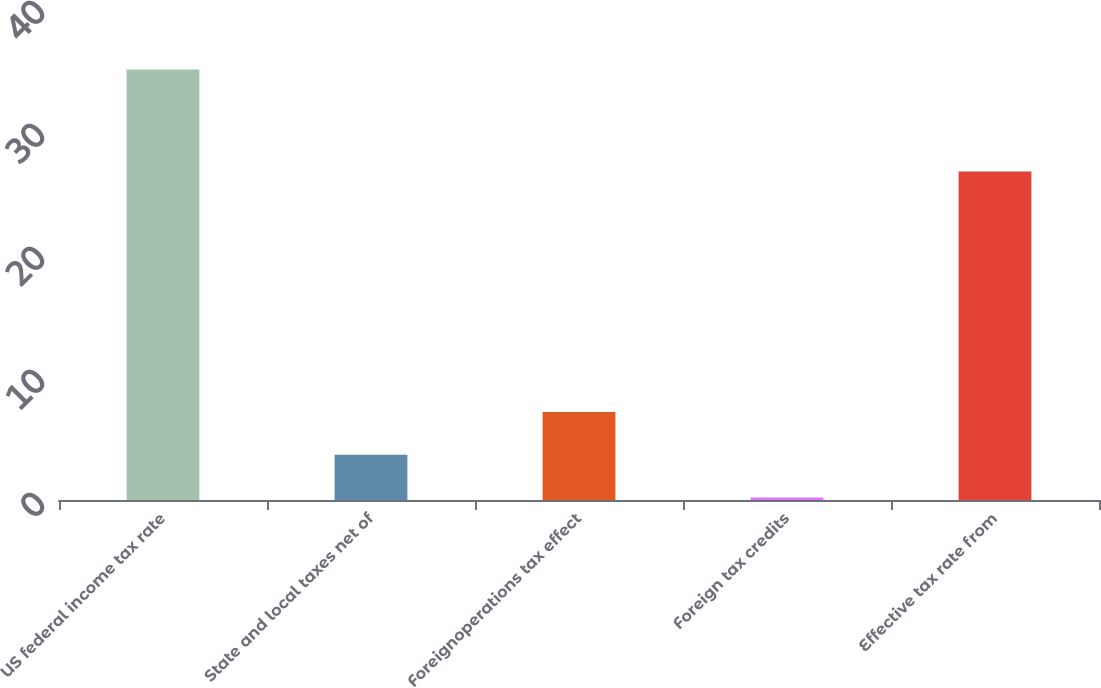Convert chart. <chart><loc_0><loc_0><loc_500><loc_500><bar_chart><fcel>US federal income tax rate<fcel>State and local taxes net of<fcel>Foreignoperations tax effect<fcel>Foreign tax credits<fcel>Effective tax rate from<nl><fcel>35<fcel>3.68<fcel>7.16<fcel>0.2<fcel>26.7<nl></chart> 